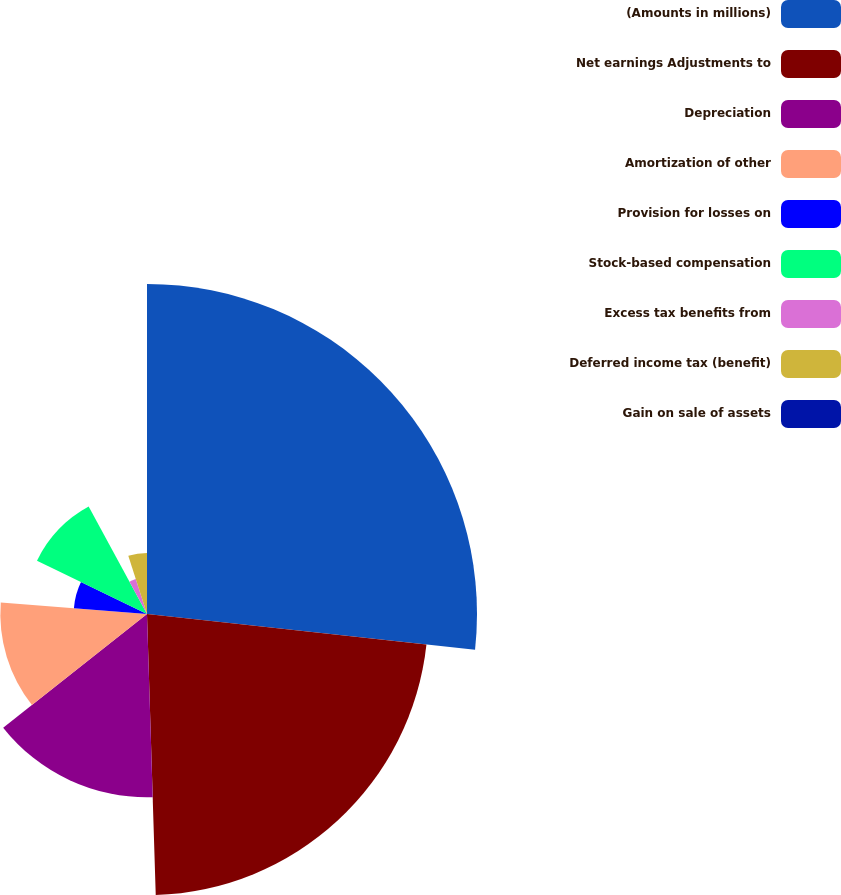Convert chart to OTSL. <chart><loc_0><loc_0><loc_500><loc_500><pie_chart><fcel>(Amounts in millions)<fcel>Net earnings Adjustments to<fcel>Depreciation<fcel>Amortization of other<fcel>Provision for losses on<fcel>Stock-based compensation<fcel>Excess tax benefits from<fcel>Deferred income tax (benefit)<fcel>Gain on sale of assets<nl><fcel>26.73%<fcel>22.77%<fcel>14.85%<fcel>11.88%<fcel>5.94%<fcel>9.9%<fcel>2.97%<fcel>4.95%<fcel>0.0%<nl></chart> 